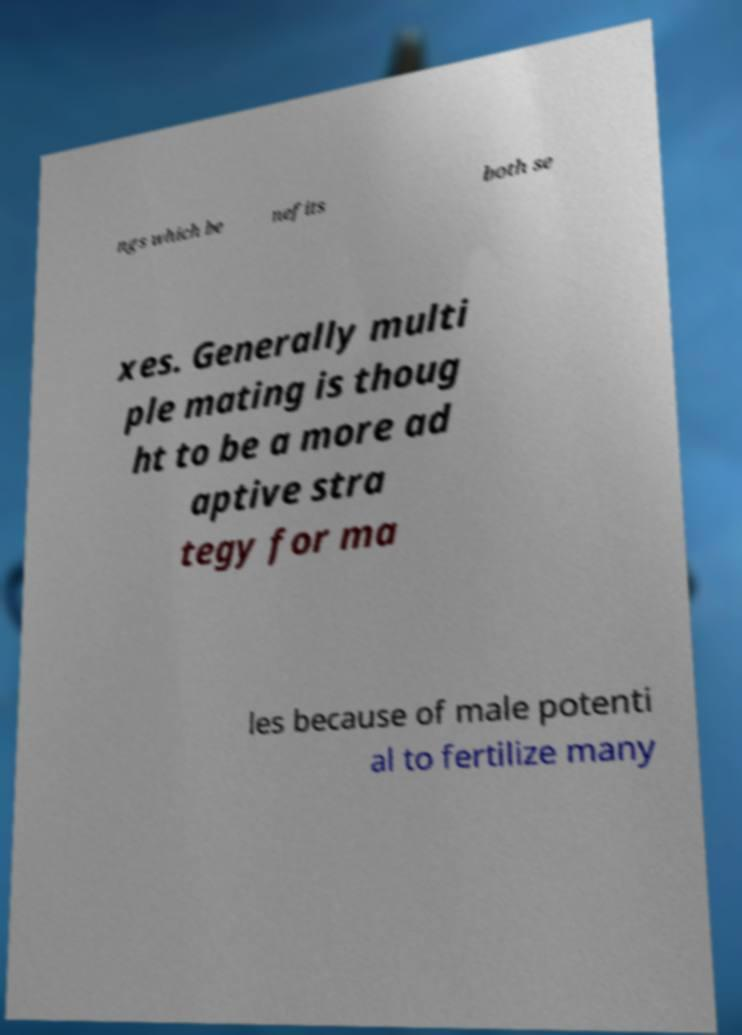I need the written content from this picture converted into text. Can you do that? ngs which be nefits both se xes. Generally multi ple mating is thoug ht to be a more ad aptive stra tegy for ma les because of male potenti al to fertilize many 